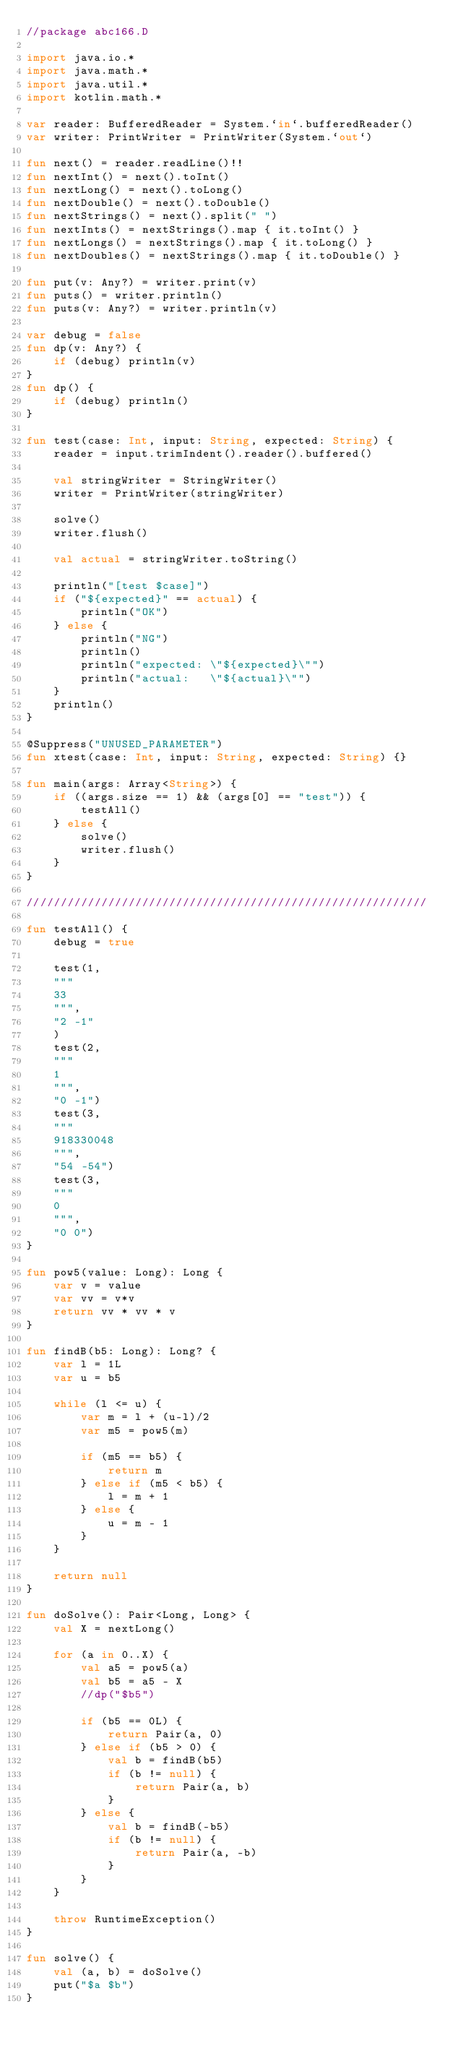<code> <loc_0><loc_0><loc_500><loc_500><_Kotlin_>//package abc166.D

import java.io.*
import java.math.*
import java.util.*
import kotlin.math.*

var reader: BufferedReader = System.`in`.bufferedReader()
var writer: PrintWriter = PrintWriter(System.`out`)

fun next() = reader.readLine()!!
fun nextInt() = next().toInt()
fun nextLong() = next().toLong()
fun nextDouble() = next().toDouble()
fun nextStrings() = next().split(" ")
fun nextInts() = nextStrings().map { it.toInt() }
fun nextLongs() = nextStrings().map { it.toLong() }
fun nextDoubles() = nextStrings().map { it.toDouble() }

fun put(v: Any?) = writer.print(v)
fun puts() = writer.println()
fun puts(v: Any?) = writer.println(v)

var debug = false
fun dp(v: Any?) {
    if (debug) println(v)
}
fun dp() {
    if (debug) println()
}

fun test(case: Int, input: String, expected: String) {
    reader = input.trimIndent().reader().buffered()

    val stringWriter = StringWriter()
    writer = PrintWriter(stringWriter)

    solve()
    writer.flush()

    val actual = stringWriter.toString()

    println("[test $case]")
    if ("${expected}" == actual) {
        println("OK")
    } else {
        println("NG")
        println()
        println("expected: \"${expected}\"")
        println("actual:   \"${actual}\"")
    }
    println()
}

@Suppress("UNUSED_PARAMETER")
fun xtest(case: Int, input: String, expected: String) {}

fun main(args: Array<String>) {
    if ((args.size == 1) && (args[0] == "test")) {
        testAll()
    } else {
        solve()
        writer.flush()
    }
}

///////////////////////////////////////////////////////////

fun testAll() {
    debug = true

    test(1,
    """
    33
    """,
    "2 -1"
    )
    test(2,
    """
    1
    """,
    "0 -1")
    test(3,
    """
    918330048
    """,
    "54 -54")
    test(3,
    """
    0
    """,
    "0 0")
}

fun pow5(value: Long): Long {
    var v = value
    var vv = v*v
    return vv * vv * v
}

fun findB(b5: Long): Long? {
    var l = 1L
    var u = b5

    while (l <= u) {
        var m = l + (u-l)/2
        var m5 = pow5(m)

        if (m5 == b5) {
            return m
        } else if (m5 < b5) {
            l = m + 1
        } else {
            u = m - 1
        }
    }

    return null
}

fun doSolve(): Pair<Long, Long> {
    val X = nextLong()

    for (a in 0..X) {
        val a5 = pow5(a)
        val b5 = a5 - X
        //dp("$b5")

        if (b5 == 0L) {
            return Pair(a, 0)
        } else if (b5 > 0) {
            val b = findB(b5)
            if (b != null) {
                return Pair(a, b)
            }
        } else {
            val b = findB(-b5)
            if (b != null) {
                return Pair(a, -b)
            }
        }
    }

    throw RuntimeException()
}

fun solve() {
    val (a, b) = doSolve()
    put("$a $b")
}
</code> 